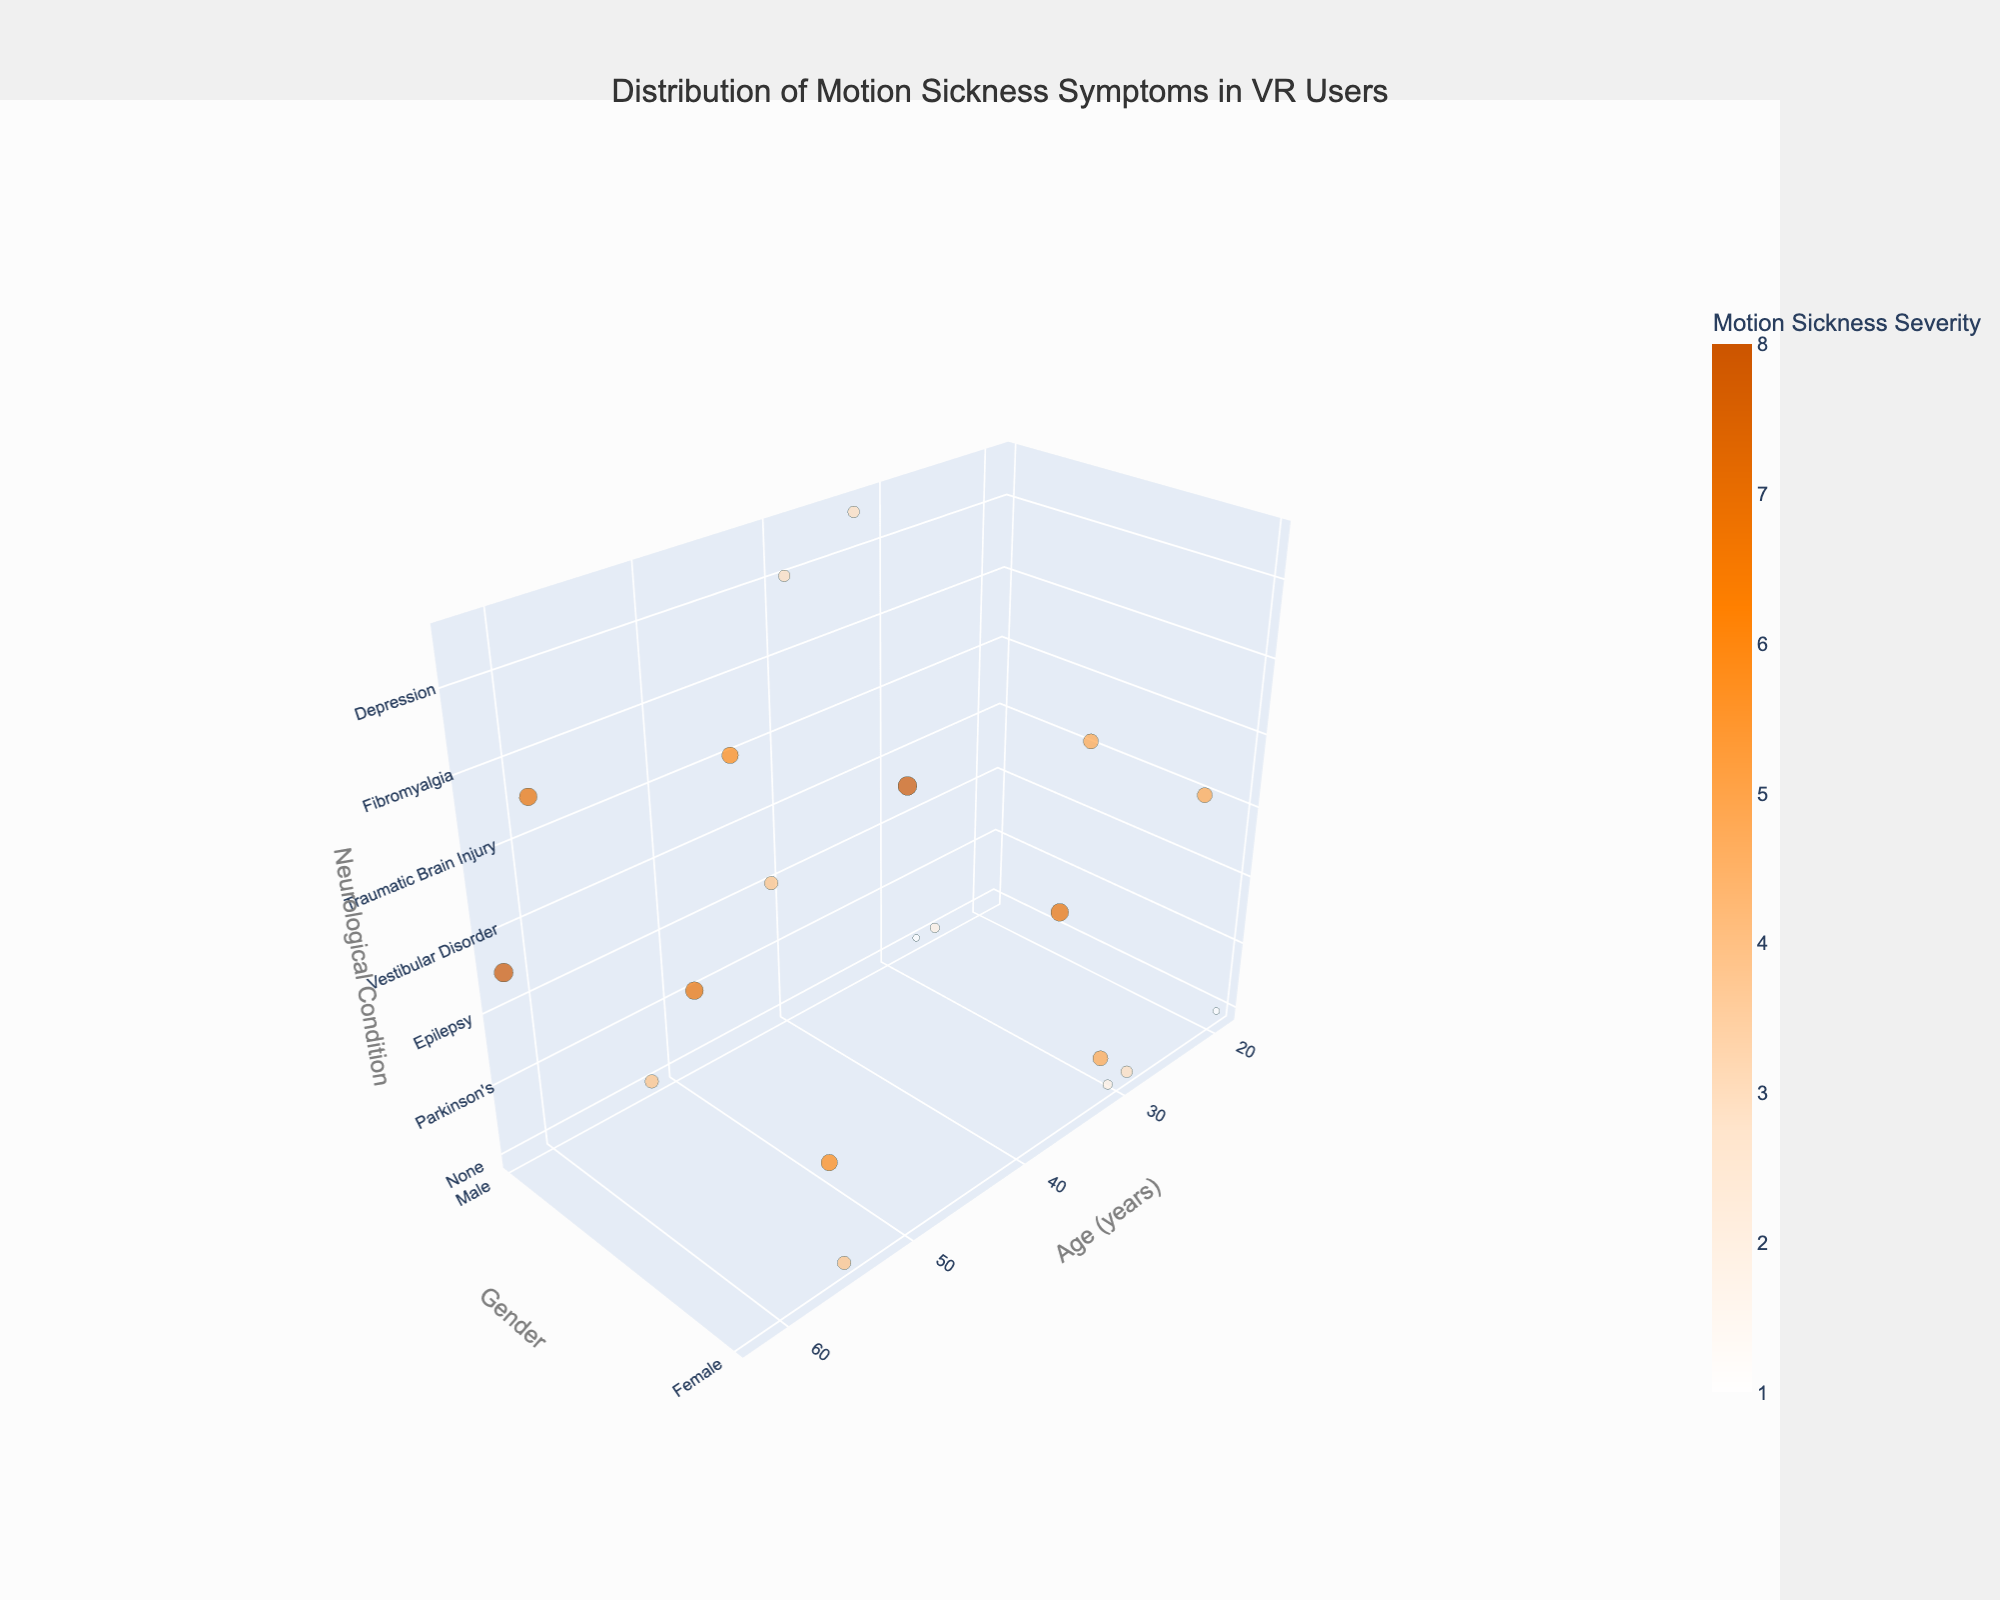How many data points are there in the plot? The plot represents individuals, with each data point corresponding to one individual in the dataset. Counting the entries in the provided data, there are 20 data points.
Answer: 20 What is the highest Motion Sickness Severity score observed in the plot? By checking the 'Motion Sickness Severity' column in the data, the highest score observed is 8.
Answer: 8 Which age group has the highest Motion Sickness Severity and what is their underlying neurological condition? The highest Motion Sickness Severity score is 8, which is shared by two age groups: 62 and 50. Their respective neurological conditions are Alzheimer’s and Vertigo.
Answer: 62 (Alzheimer's), 50 (Vertigo) Are there more males or females in the dataset? By counting the 'Male' and 'Female' entries in the 'Gender' column, there are 8 males and 12 females in the dataset.
Answer: Females What is the average Motion Sickness Severity score for users with 'None' neurological condition? Summing the Motion Sickness Severity scores for users with 'None' as their neurological condition (2, 1, 3, 4, 2, 4, 1) and dividing by the number of such users (7), we get (2+1+3+4+2+4+1)/7 = 2.43.
Answer: 2.43 How does the Motion Sickness Severity of the youngest individual compare to the oldest? The youngest individual is 19 years old with a severity score of 1, and the oldest is 62 years old with a severity score of 8. 1 is significantly lower than 8.
Answer: The youngest has a lower severity score Is there any pattern between gender and Motion Sickness Severity in users with neurological conditions? Comparing the severity scores across genders for users with conditions, females (Migraine: 5, Multiple Sclerosis: 6, Vestibular Disorder: 7, Anxiety Disorder: 5, Fibromyalgia: 5, Vertigo: 8) tend to have higher scores than males (Parkinson's: 7, Epilepsy: 4, Alzheimer's: 8, Traumatic Brain Injury: 6, Stroke: 7, Depression: 3, ADHD: 3).
Answer: Females tend to have higher severity What is the range of ages for users with Motion Sickness Severity scores of 5 or higher? Severity scores of 5 or higher are observed in users aged 32, 56, 62, 37, 23, 44, 50, 59, 35. The age range is from 23 to 62.
Answer: 23 to 62 Identify the individual with the lowest Motion Sickness Severity score and their neurological condition. The lowest severity score is 1, observed in two individuals aged 19 and 27, both having 'None' as their neurological condition.
Answer: 19, 27 (None) 